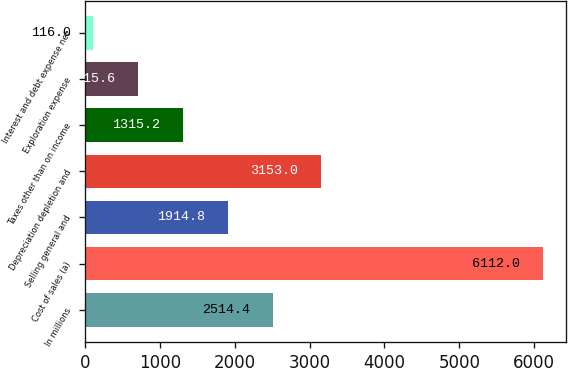Convert chart to OTSL. <chart><loc_0><loc_0><loc_500><loc_500><bar_chart><fcel>In millions<fcel>Cost of sales (a)<fcel>Selling general and<fcel>Depreciation depletion and<fcel>Taxes other than on income<fcel>Exploration expense<fcel>Interest and debt expense net<nl><fcel>2514.4<fcel>6112<fcel>1914.8<fcel>3153<fcel>1315.2<fcel>715.6<fcel>116<nl></chart> 